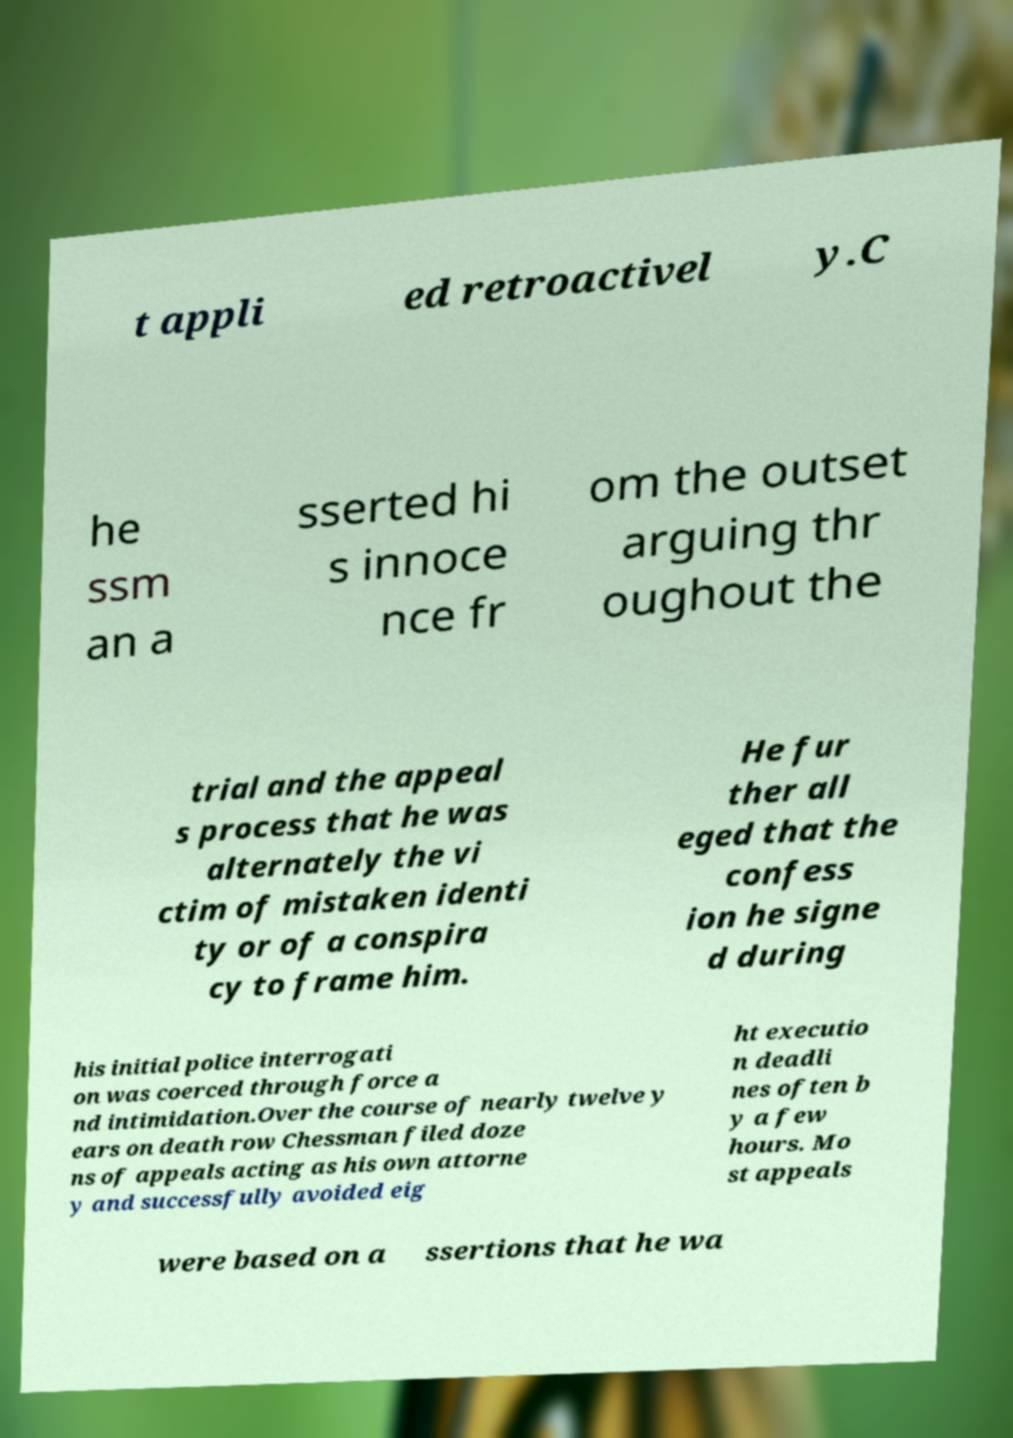Please read and relay the text visible in this image. What does it say? t appli ed retroactivel y.C he ssm an a sserted hi s innoce nce fr om the outset arguing thr oughout the trial and the appeal s process that he was alternately the vi ctim of mistaken identi ty or of a conspira cy to frame him. He fur ther all eged that the confess ion he signe d during his initial police interrogati on was coerced through force a nd intimidation.Over the course of nearly twelve y ears on death row Chessman filed doze ns of appeals acting as his own attorne y and successfully avoided eig ht executio n deadli nes often b y a few hours. Mo st appeals were based on a ssertions that he wa 